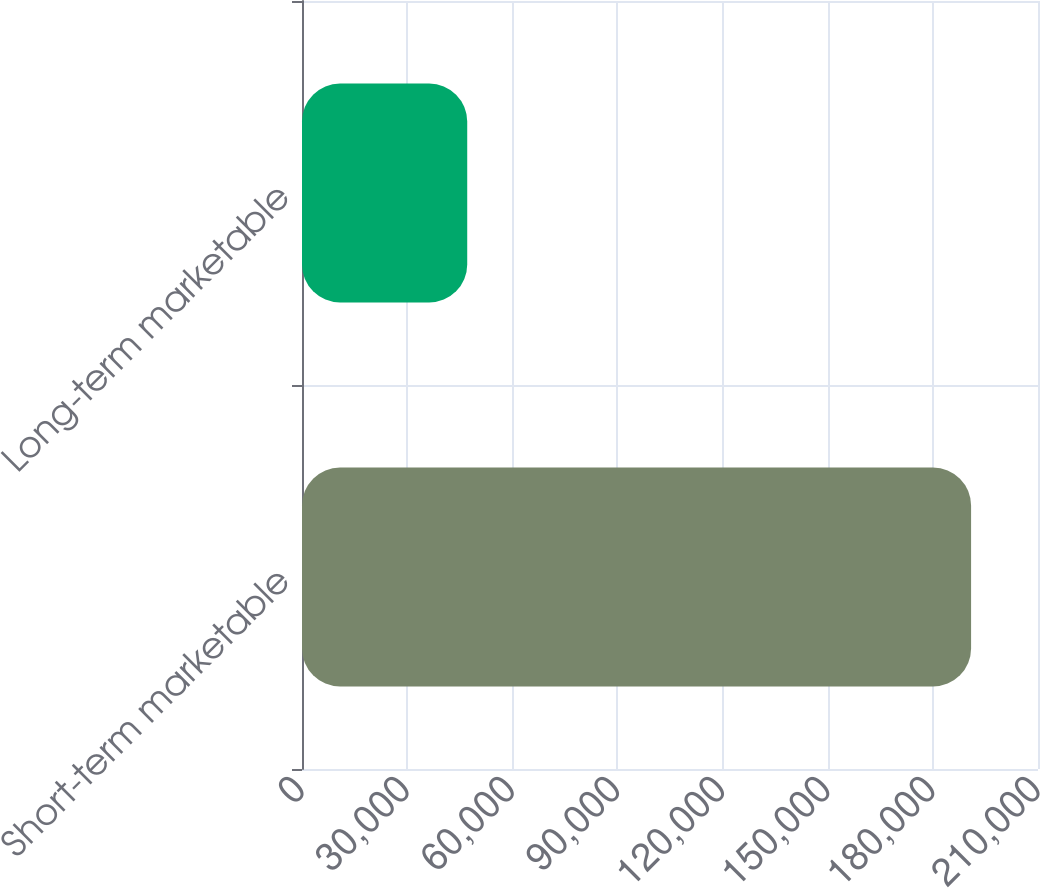Convert chart. <chart><loc_0><loc_0><loc_500><loc_500><bar_chart><fcel>Short-term marketable<fcel>Long-term marketable<nl><fcel>190908<fcel>47143<nl></chart> 